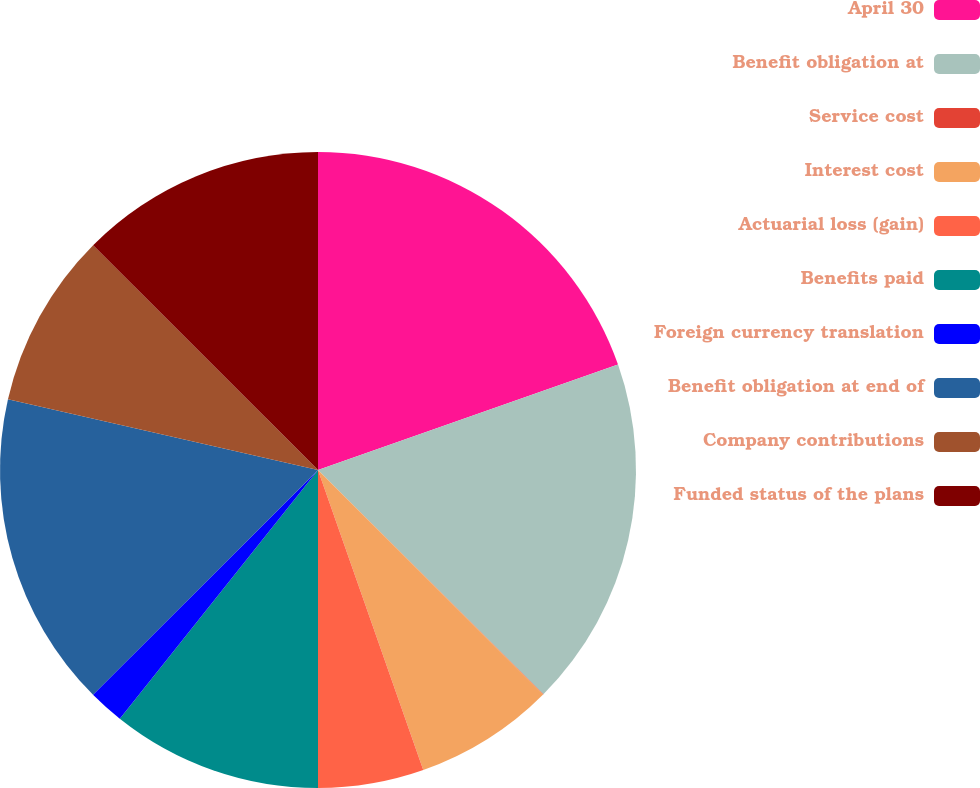Convert chart. <chart><loc_0><loc_0><loc_500><loc_500><pie_chart><fcel>April 30<fcel>Benefit obligation at<fcel>Service cost<fcel>Interest cost<fcel>Actuarial loss (gain)<fcel>Benefits paid<fcel>Foreign currency translation<fcel>Benefit obligation at end of<fcel>Company contributions<fcel>Funded status of the plans<nl><fcel>19.62%<fcel>17.84%<fcel>0.02%<fcel>7.15%<fcel>5.37%<fcel>10.71%<fcel>1.8%<fcel>16.06%<fcel>8.93%<fcel>12.5%<nl></chart> 